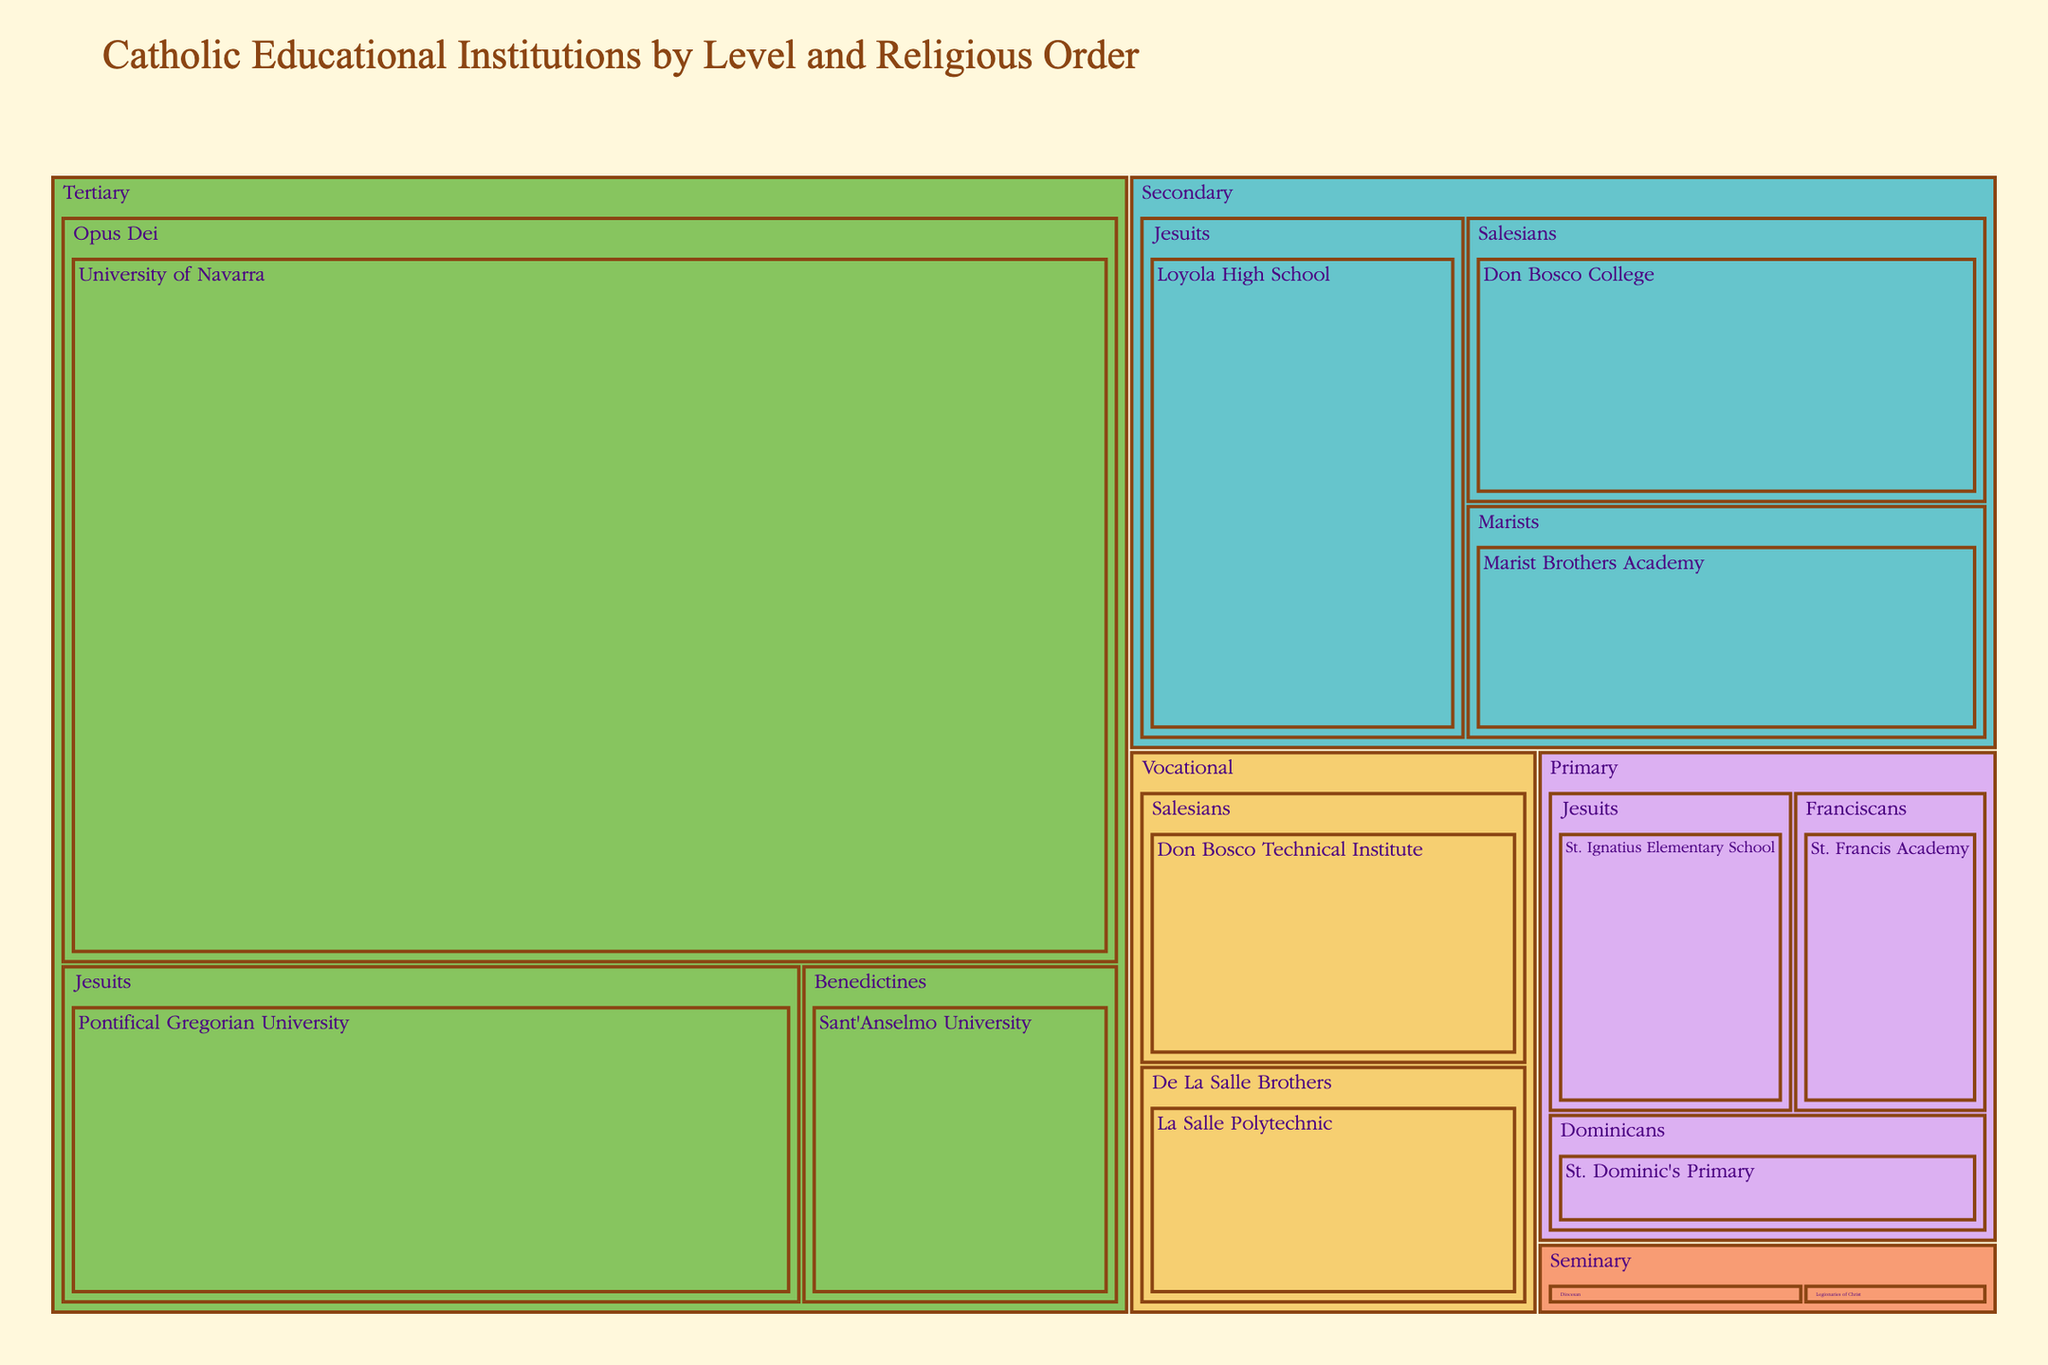What's the total number of students in primary-level institutions? Sum the number of students in each primary institution: St. Ignatius Elementary School (1200), St. Francis Academy (950), and St. Dominic's Primary (800), which equals 1200 + 950 + 800 = 2950
Answer: 2950 Which tertiary institution has the highest number of students? Review the number of students in each tertiary institution: Pontifical Gregorian University (3500), Sant'Anselmo University (1500), and University of Navarra (11000). The highest is University of Navarra.
Answer: University of Navarra How many religious orders are represented in the secondary level institutions? Count the different religious orders in the secondary level from the tree map: Jesuits, Salesians, Marists. There are three.
Answer: 3 Are there more students in vocational-level institutions or seminary-level institutions? Sum the number of students in each level: Vocational (Don Bosco Technical Institute - 1600, La Salle Polytechnic - 1400) = 3000; Seminary (Pontifical North American College - 250, Legion of Christ Seminary - 180) = 430. Vocational has more than Seminary.
Answer: Vocational What is the combined total number of students taught by the Jesuits across all levels? Sum the number of students in Jesuit institutions: St. Ignatius Elementary School (1200), Loyola High School (2500), Pontifical Gregorian University (3500). The total is 1200 + 2500 + 3500 = 7200.
Answer: 7200 Which religious order has the smallest number of students in their institutions? Identify each order and sum their students, the order with the lowest total is:
Franciscans (950), Dominicans (800), Salesians (3800), Marists (1800), Benedictines (1500), Opus Dei (11000), De La Salle Brothers (1400), Diocesan (250), Legionaries of Christ (180). Legionaries of Christ has the least number of students.
Answer: Legionaries of Christ What percentage of the total students are enrolled in tertiary-level institutions? Sum the number of students in tertiary institutions: Pontifical Gregorian University (3500), Sant'Anselmo University (1500), University of Navarra (11000) = 16000; Sum the total number of students: 2950 (Primary) + 6500 (Secondary) + 16000 (Tertiary) + 3000 (Vocational) + 430 (Seminary) = 28880; (16000 / 28880) * 100 = 55.4%.
Answer: 55.4% Which level has the second-highest number of students enrolled? Sum the number of students for each level and identify the second highest: Primary (2950), Secondary (6500), Tertiary (16000), Vocational (3000), Seminary (430). Vocational has the second highest after Tertiary.
Answer: Secondary How many levels have institutions run by the Salesians? Identify levels with Salesian institutions: Secondary (Don Bosco College) and Vocational (Don Bosco Technical Institute). There are two levels.
Answer: 2 